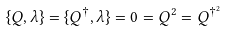<formula> <loc_0><loc_0><loc_500><loc_500>\{ Q , \lambda \} = \{ Q ^ { \dagger } , \lambda \} = 0 = Q ^ { 2 } = Q ^ { \dagger ^ { 2 } }</formula> 